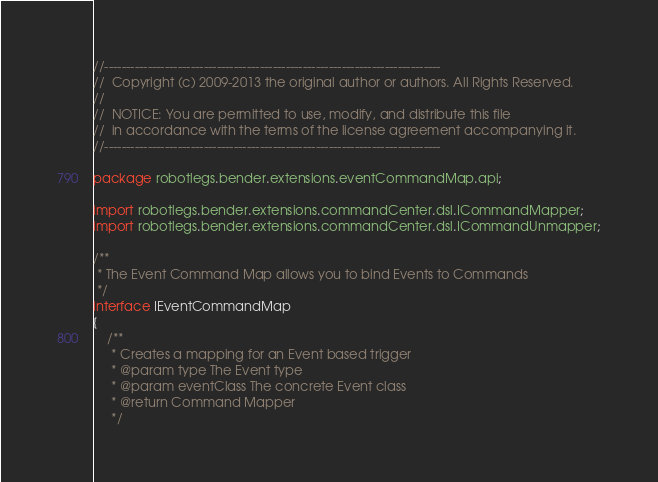<code> <loc_0><loc_0><loc_500><loc_500><_Haxe_>//------------------------------------------------------------------------------
//  Copyright (c) 2009-2013 the original author or authors. All Rights Reserved. 
// 
//  NOTICE: You are permitted to use, modify, and distribute this file 
//  in accordance with the terms of the license agreement accompanying it. 
//------------------------------------------------------------------------------

package robotlegs.bender.extensions.eventCommandMap.api;

import robotlegs.bender.extensions.commandCenter.dsl.ICommandMapper;
import robotlegs.bender.extensions.commandCenter.dsl.ICommandUnmapper;

/**
 * The Event Command Map allows you to bind Events to Commands
 */
interface IEventCommandMap
{
	/**
	 * Creates a mapping for an Event based trigger
	 * @param type The Event type
	 * @param eventClass The concrete Event class
	 * @return Command Mapper
	 */</code> 